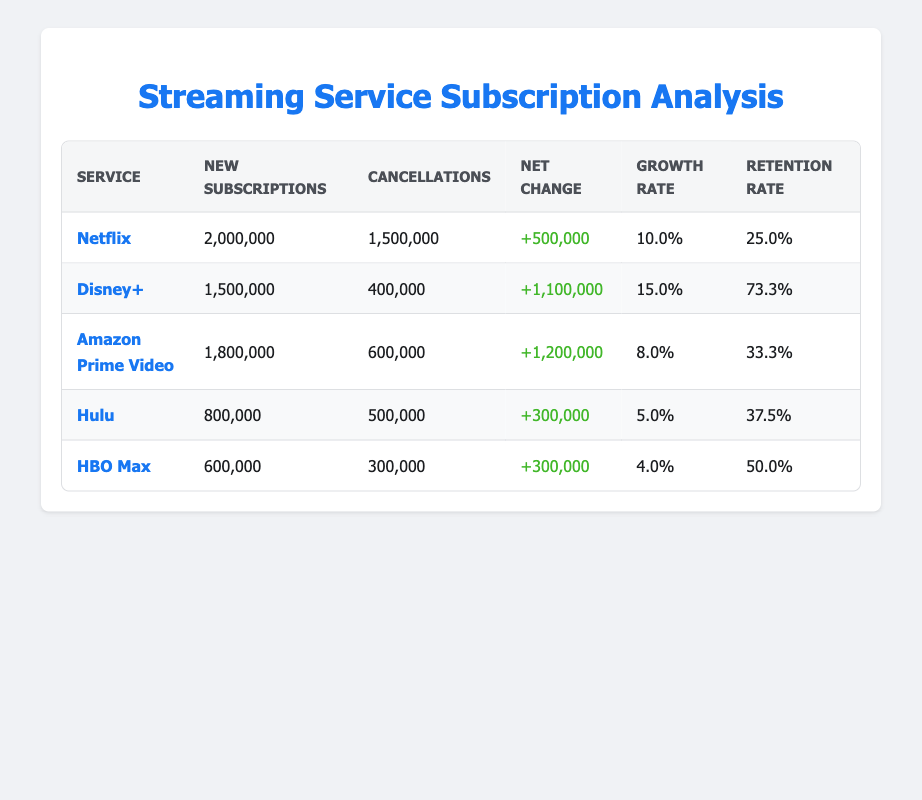What is the net change of subscriptions for Disney+? The "Net Change" column for Disney+ shows a value of +1,100,000, indicating that the number of new subscriptions minus cancellations leads to this net increase.
Answer: +1,100,000 Which streaming service had the highest new subscriptions? By comparing the values in the "New Subscriptions" column, Netflix has 2,000,000 new subscriptions, which is higher than the others (Disney+: 1,500,000; Amazon Prime Video: 1,800,000; Hulu: 800,000; HBO Max: 600,000).
Answer: Netflix What is the average retention rate across all services? The retention rates are 25.0%, 73.3%, 33.3%, 37.5%, and 50.0%. Adding these values gives 219.1%. Dividing by 5, the average retention rate is 43.82%.
Answer: 43.82% Did HBO Max have more new subscriptions than Hulu? HBO Max had 600,000 new subscriptions, while Hulu had 800,000. Therefore, Hulu had more new subscriptions than HBO Max. This makes the statement false.
Answer: No What is the total number of cancellations across all services? To find the total cancellations, we add the cancellations for each service: 1,500,000 (Netflix) + 400,000 (Disney+) + 600,000 (Amazon Prime Video) + 500,000 (Hulu) + 300,000 (HBO Max) = 3,300,000.
Answer: 3,300,000 Which service had the lowest growth rate, and what was that rate? By examining the "Growth Rate" column, we find HBO Max with the lowest growth rate of 4.0%.
Answer: HBO Max, 4.0% How many services had a retention rate greater than 30%? The retention rates are 25.0%, 73.3%, 33.3%, 37.5%, and 50.0%. The rates greater than 30% belong to Disney+, Amazon Prime Video, Hulu, and HBO Max. There are 4 services in total.
Answer: 4 What is the difference between new subscriptions for Amazon Prime Video and Hulu? Amazon Prime Video had 1,800,000 new subscriptions and Hulu had 800,000. The difference is 1,800,000 - 800,000 = 1,000,000.
Answer: 1,000,000 Which streaming service has the highest cancellation rate relative to new subscriptions? To find the highest cancellation rate relative to new subscriptions, calculate the cancellation rate for each service: Netflix: 75.0%, Disney+: 26.7%, Amazon Prime Video: 33.3%, Hulu: 62.5%, HBO Max: 50.0%. The highest is for Netflix at 75.0%.
Answer: Netflix, 75.0% 